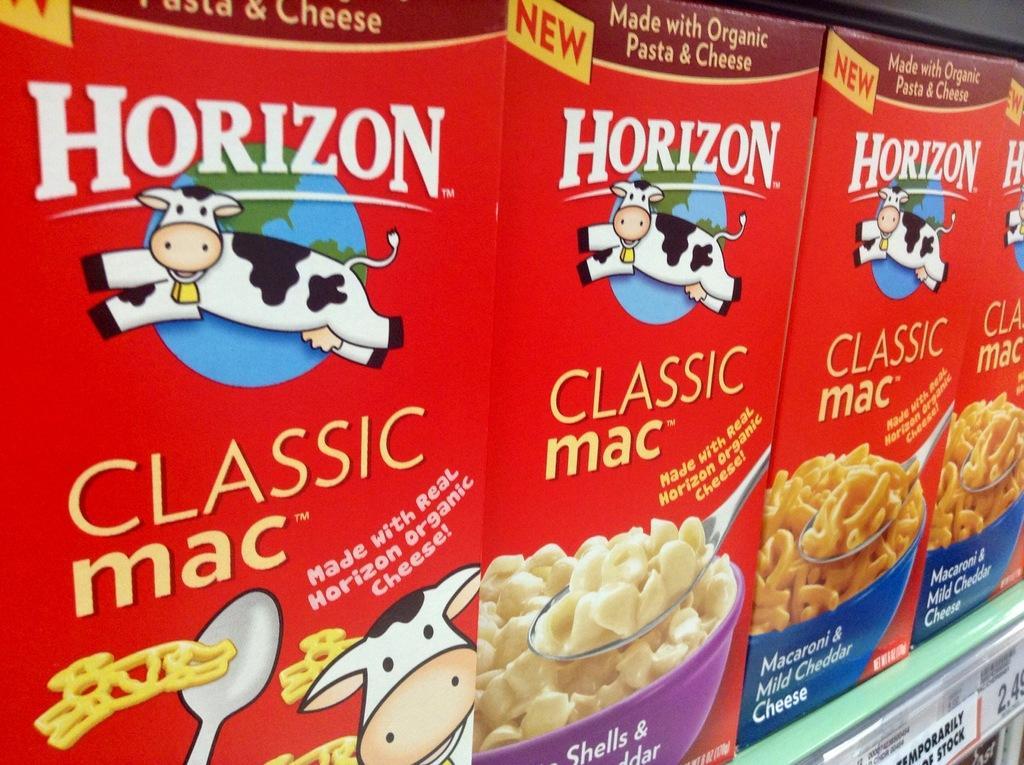Describe this image in one or two sentences. Here we can see food packets on the racks and on the right side at the bottom corner we can see price tags on the rack. 